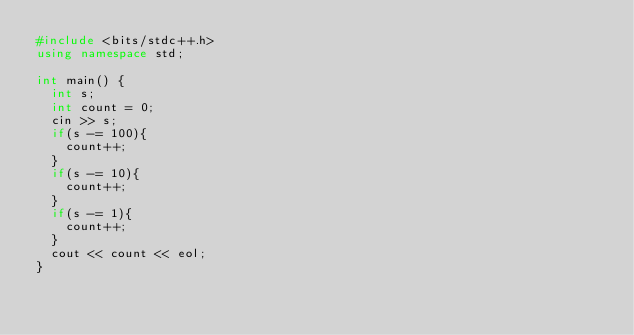<code> <loc_0><loc_0><loc_500><loc_500><_C++_>#include <bits/stdc++.h>
using namespace std;

int main() {
  int s;
  int count = 0;
  cin >> s;
  if(s -= 100){
    count++;
  }
  if(s -= 10){
    count++;
  }
  if(s -= 1){
    count++;
  }
  cout << count << eol;
}
</code> 